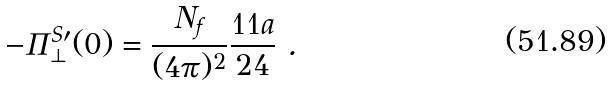Convert formula to latex. <formula><loc_0><loc_0><loc_500><loc_500>- \Pi ^ { S \prime } _ { \perp } ( 0 ) = \frac { N _ { f } } { ( 4 \pi ) ^ { 2 } } \frac { 1 1 a } { 2 4 } \ .</formula> 